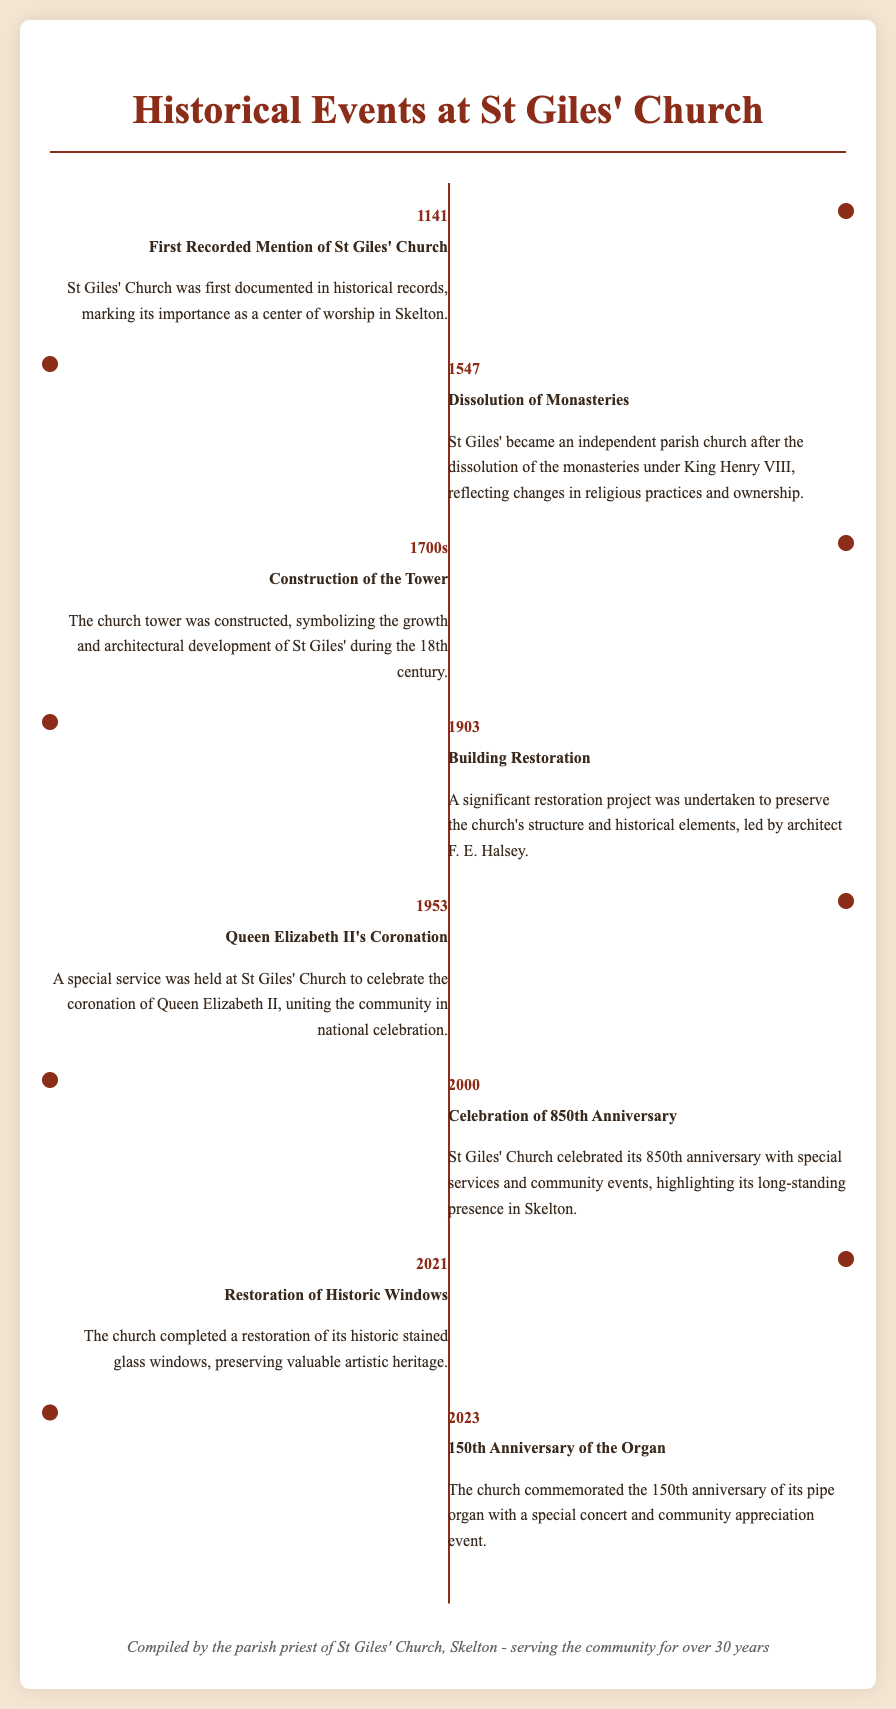What year was St Giles' Church first recorded? The document states that St Giles' Church was first recorded in the year 1141.
Answer: 1141 What significant event happened at St Giles' Church in 1547? According to the document, St Giles' became an independent parish church after the dissolution of the monasteries in 1547.
Answer: Dissolution of Monasteries Who was the architect responsible for the church's restoration in 1903? The document mentions that architect F. E. Halsey led the restoration of the church in 1903.
Answer: F. E. Halsey What anniversary was celebrated at St Giles' Church in the year 2000? The document indicates that St Giles' Church celebrated its 850th anniversary in 2000.
Answer: 850th Anniversary What was commemorated in 2023 at St Giles' Church? The document notes that the church commemorated the 150th anniversary of its pipe organ in 2023.
Answer: 150th Anniversary of the Organ In which year did a special service take place for Queen Elizabeth II's Coronation? The document highlights that a special service was held in 1953 to celebrate Queen Elizabeth II's coronation.
Answer: 1953 What architectural feature was constructed during the 1700s at St Giles' Church? The document states that the tower of the church was constructed in the 1700s.
Answer: The Tower What community activity occurred alongside the celebration of the 150th anniversary of the organ? The document mentions that a special concert and community appreciation event occurred with the organ anniversary in 2023.
Answer: Special concert and community appreciation event 